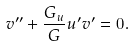<formula> <loc_0><loc_0><loc_500><loc_500>v ^ { \prime \prime } + \frac { G _ { u } } { G } u ^ { \prime } v ^ { \prime } = 0 .</formula> 